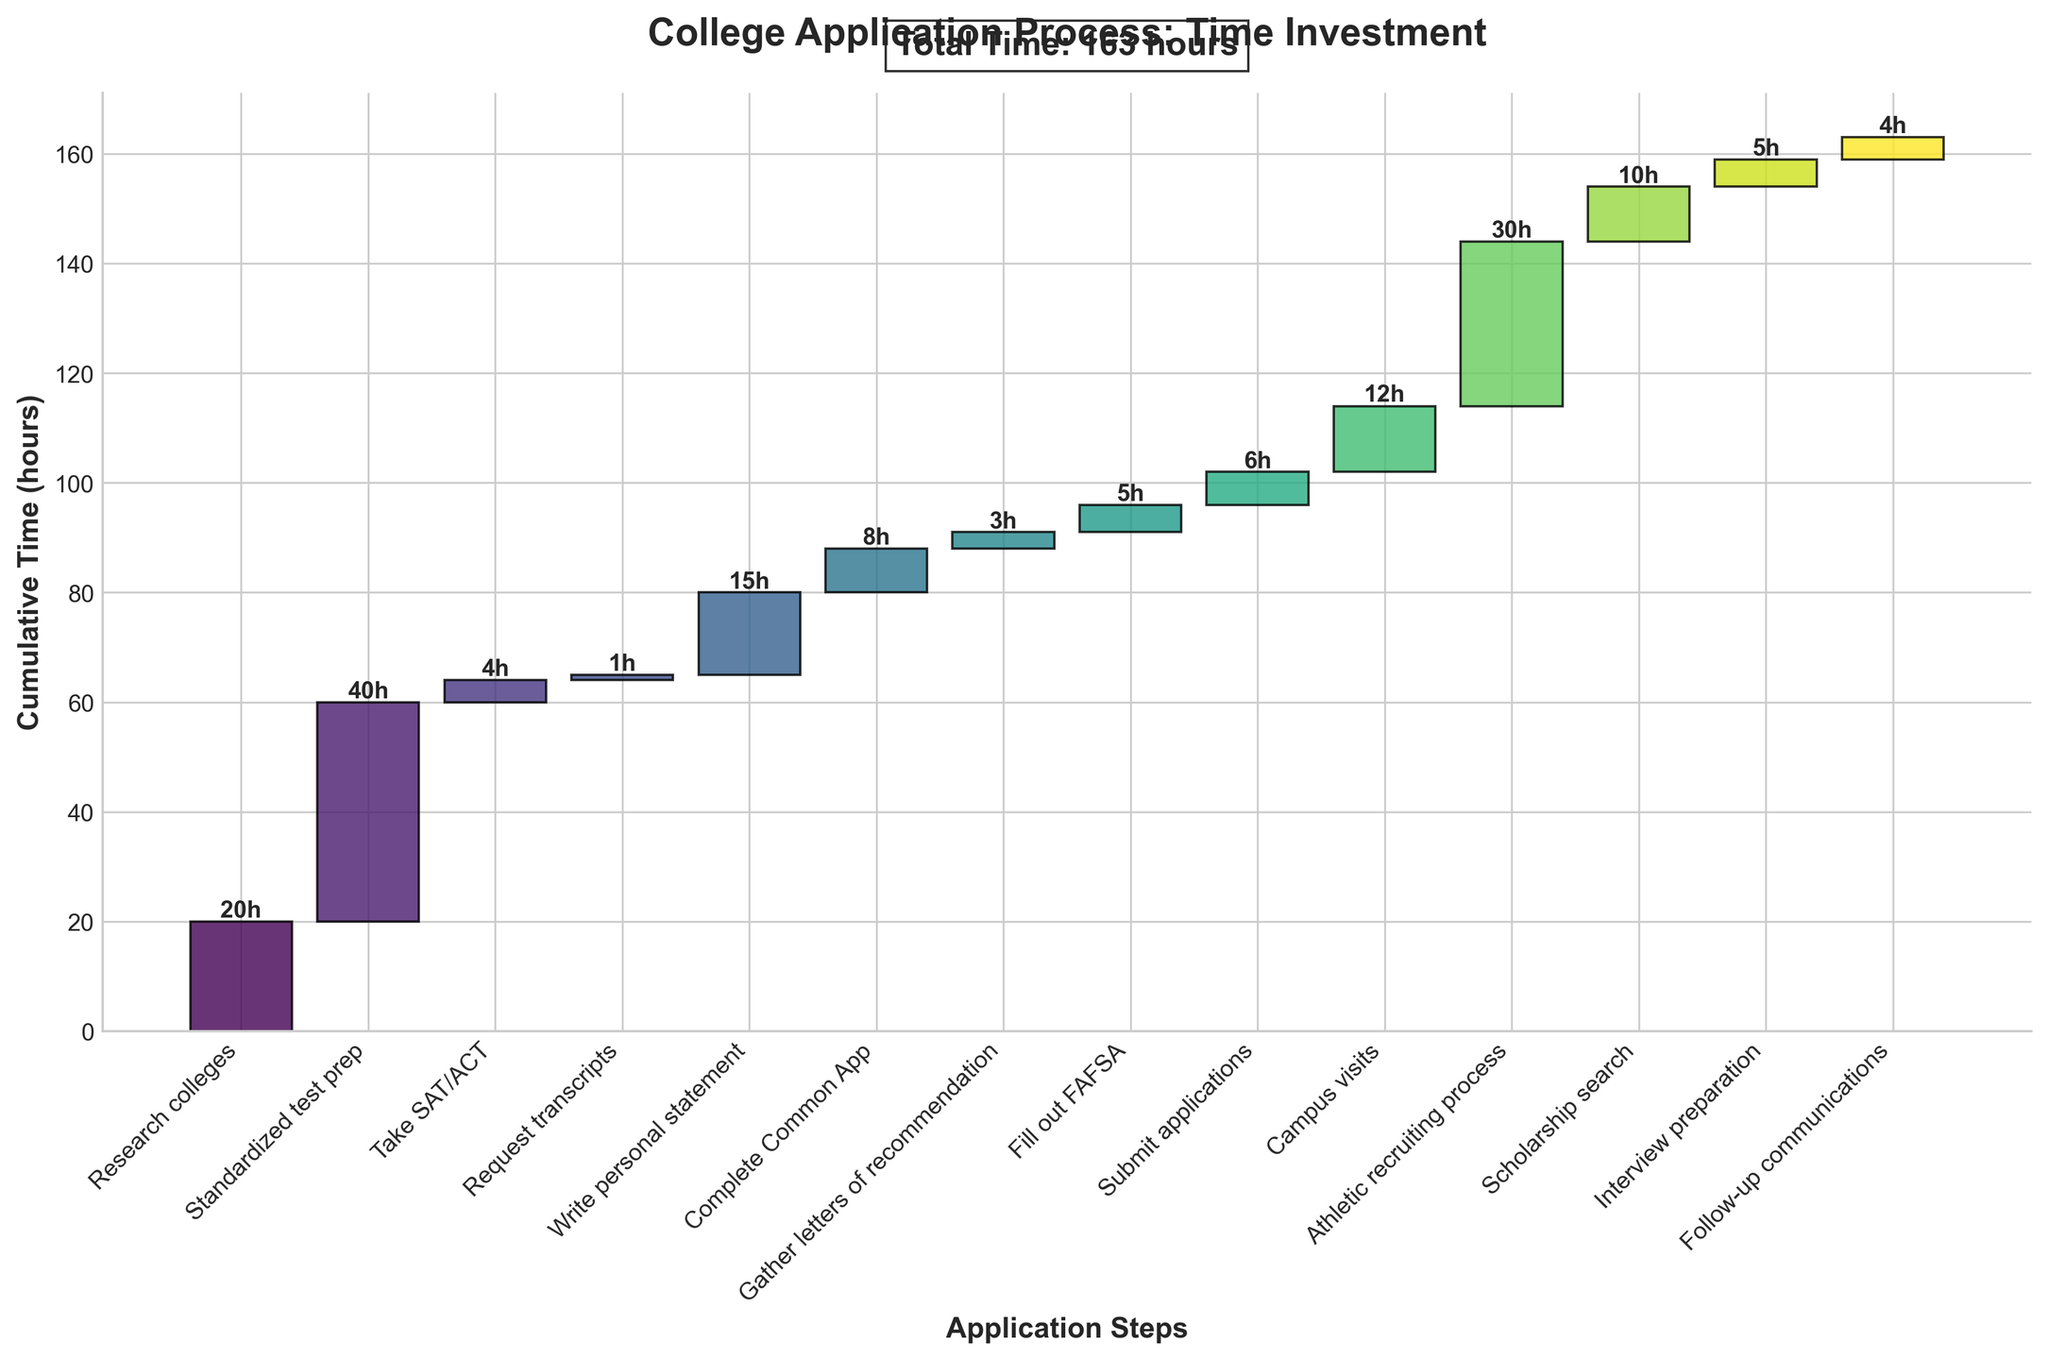what is the total time invested in the college application process? Sum up all the time invested in different steps shown in the chart. The total time is displayed at the top center of the figure, which is 168 hours.
Answer: 168 hours What is the title of the chart? The title of the chart is displayed at the top.
Answer: College Application Process: Time Investment Which step took the most time to complete? Look at the height of the bars; the step with the highest bar is the one that took the most time.
Answer: Standardized test prep How many steps are involved in the college application process according to the chart? Count the number of unique steps on the x-axis of the chart. There are 14 steps listed.
Answer: 14 What is the cumulative time after completing the athletic recruiting process? Find the bar labeled "Athletic recruiting process" and note its cumulative value at the top of the bar.
Answer: 144 hours How much time is spent on both completing the Common App and gathering letters of recommendation combined? Add the time for "Complete Common App" (8 hours) and "Gather letters of recommendation" (3 hours).
Answer: 11 hours How does the time invested in campus visits compare to the time spent on scholarship search? Compare the heights of the bars for "Campus visits" (12 hours) and "Scholarship search" (10 hours).
Answer: Campus visits took 2 hours more than scholarship search Which step takes the least time to complete? Look for the bar with the smallest height; the step labeled "Request transcripts" has the smallest bar.
Answer: Request transcripts What steps are completed after 40 hours of cumulative time? Identify the steps whose cumulative time is greater than or equal to 40 hours by inspecting the cumulative values at the top of the bars. The steps are "Research colleges," "Standardized test prep," and "Take SAT/ACT."
Answer: Research colleges, Standardized test prep, Take SAT/ACT What is the cumulative time after completing the interview preparation? Find the bar labeled "Interview preparation" and note its cumulative value at the top of the bar.
Answer: 163 hours 